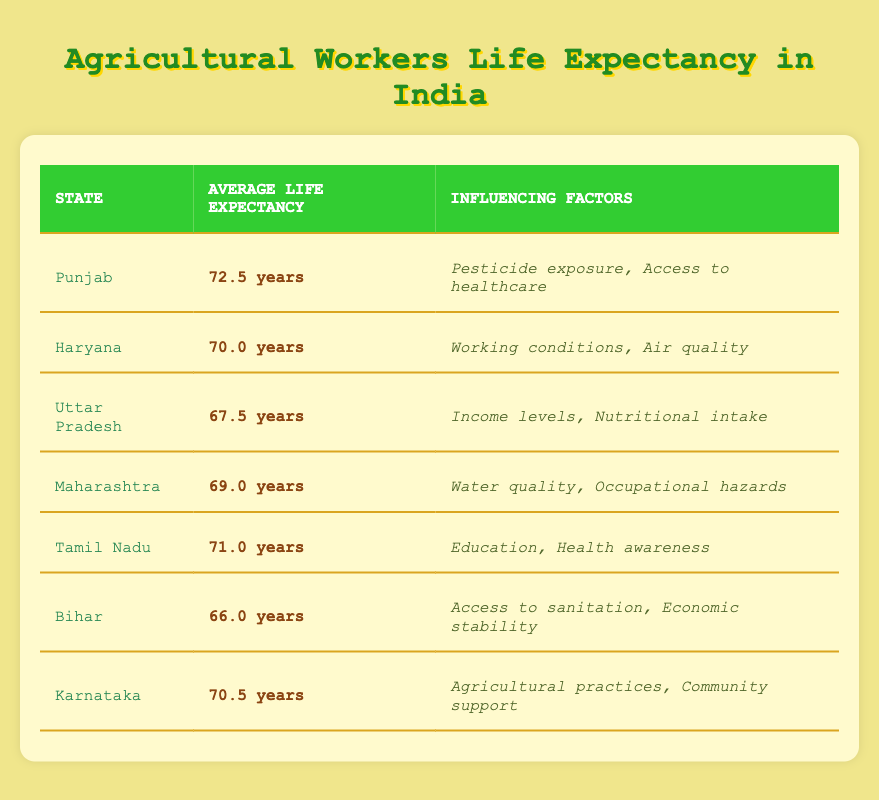What is the average life expectancy of agricultural workers in Punjab? The table shows that the average life expectancy in Punjab is listed as 72.5 years. Therefore, we can directly retrieve this value from the table.
Answer: 72.5 years Which state has the lowest average life expectancy for agricultural workers? By inspecting the table, I can see that Bihar has the lowest average life expectancy, which is 66.0 years. This is the minimum value among all listed states.
Answer: Bihar What are the factors influencing life expectancy in Haryana? The table specifies that the factors influencing life expectancy in Haryana are "Working conditions" and "Air quality." I can find these factors directly in the corresponding row.
Answer: Working conditions, Air quality What is the average life expectancy of agricultural workers in Tamil Nadu and Karnataka? To find the average, I will take the values from the table: Tamil Nadu has 71.0 years and Karnataka has 70.5 years. Adding these gives 71.0 + 70.5 = 141.5 years. To find the average, divide this sum by two: 141.5 / 2 = 70.75 years.
Answer: 70.75 years Do agricultural workers in Maharashtra have a higher life expectancy than those in Uttar Pradesh? The table reveals that the average life expectancy in Maharashtra is 69.0 years and in Uttar Pradesh it is 67.5 years. Since 69.0 is greater than 67.5, the statement is true.
Answer: Yes Which state has an average life expectancy greater than 70 years? I will check each state's average life expectancy. Punjab (72.5), Tamil Nadu (71.0), and Karnataka (70.5) all exceed 70 years, while the others do not. Hence, the states that meet this criterion are Punjab, Tamil Nadu, and Karnataka.
Answer: Punjab, Tamil Nadu, Karnataka What is the difference in average life expectancy between agricultural workers in Uttar Pradesh and Bihar? From the table, Uttar Pradesh has an average life expectancy of 67.5 years, and Bihar has 66.0 years. To find the difference, I subtract the average of Bihar from Uttar Pradesh: 67.5 - 66.0 = 1.5 years.
Answer: 1.5 years Which factors influence the life expectancy of agricultural workers in Tamil Nadu? The table indicates that the factors are "Education" and "Health awareness." These can be directly identified in the row for Tamil Nadu.
Answer: Education, Health awareness 